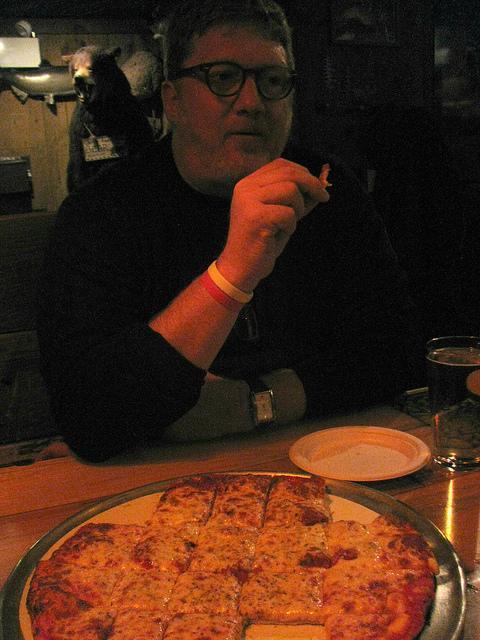Does the image validate the caption "The person is touching the pizza."?
Answer yes or no. Yes. 